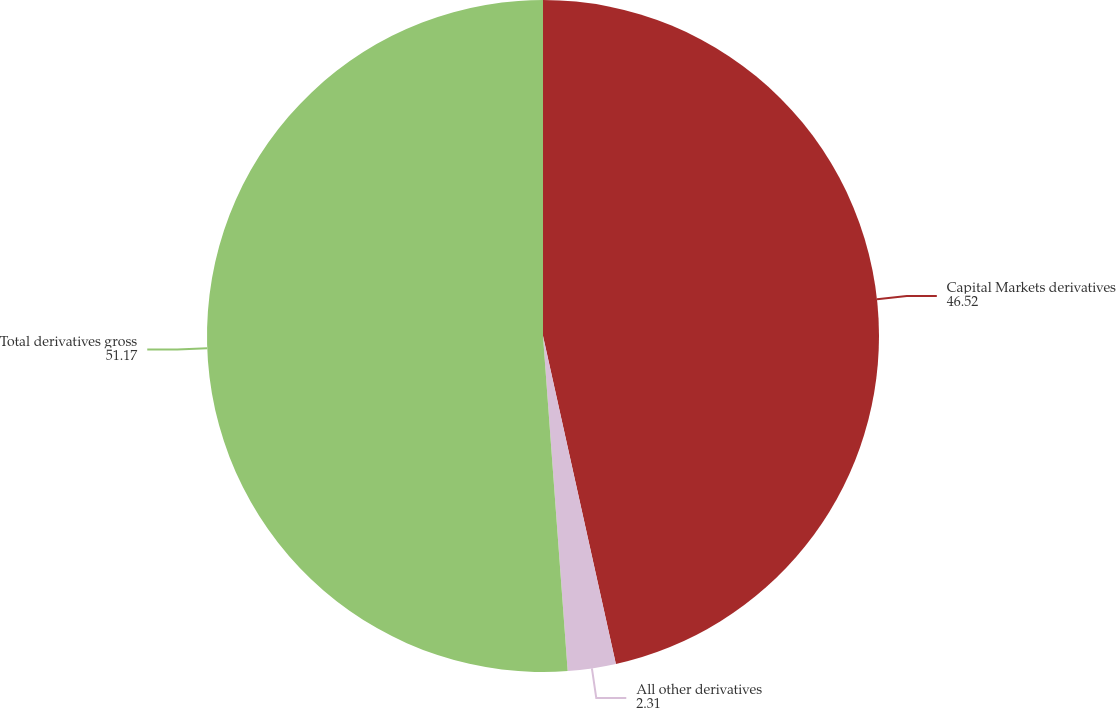Convert chart to OTSL. <chart><loc_0><loc_0><loc_500><loc_500><pie_chart><fcel>Capital Markets derivatives<fcel>All other derivatives<fcel>Total derivatives gross<nl><fcel>46.52%<fcel>2.31%<fcel>51.17%<nl></chart> 